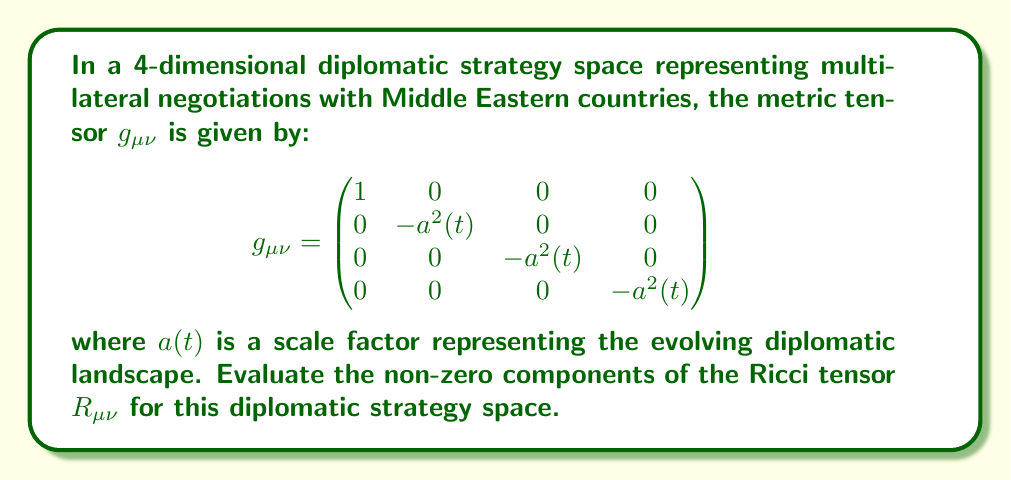What is the answer to this math problem? To evaluate the Ricci tensor, we'll follow these steps:

1) First, we need to calculate the Christoffel symbols $\Gamma^\lambda_{\mu\nu}$ using the metric tensor:

   $$\Gamma^\lambda_{\mu\nu} = \frac{1}{2}g^{\lambda\sigma}(\partial_\mu g_{\nu\sigma} + \partial_\nu g_{\mu\sigma} - \partial_\sigma g_{\mu\nu})$$

2) The non-zero Christoffel symbols are:
   
   $$\Gamma^0_{ii} = a\dot{a}, \quad \Gamma^i_{0i} = \Gamma^i_{i0} = \frac{\dot{a}}{a}$$
   
   where $i = 1, 2, 3$ and $\dot{a} = \frac{da}{dt}$

3) Next, we use the Christoffel symbols to calculate the Ricci tensor:

   $$R_{\mu\nu} = \partial_\lambda \Gamma^\lambda_{\mu\nu} - \partial_\nu \Gamma^\lambda_{\mu\lambda} + \Gamma^\lambda_{\lambda\sigma}\Gamma^\sigma_{\mu\nu} - \Gamma^\lambda_{\nu\sigma}\Gamma^\sigma_{\mu\lambda}$$

4) Calculating the non-zero components:

   For $R_{00}$:
   $$R_{00} = \partial_i \Gamma^i_{00} + \Gamma^i_{i\lambda}\Gamma^\lambda_{00} - \Gamma^i_{0\lambda}\Gamma^\lambda_{0i} = 3\frac{\ddot{a}}{a}$$

   For $R_{ii}$ (no sum on $i$):
   $$R_{ii} = \partial_0 \Gamma^0_{ii} + \partial_j \Gamma^j_{ii} - \Gamma^0_{i\lambda}\Gamma^\lambda_{0i} - \Gamma^j_{i\lambda}\Gamma^\lambda_{ij} = a\ddot{a} + 2\dot{a}^2$$

5) The non-zero components of the Ricci tensor are:

   $$R_{00} = 3\frac{\ddot{a}}{a}$$
   $$R_{11} = R_{22} = R_{33} = a\ddot{a} + 2\dot{a}^2$$

These components represent the curvature of the diplomatic strategy space, reflecting how diplomatic relations evolve over time in multi-lateral negotiations.
Answer: $R_{00} = 3\frac{\ddot{a}}{a}$, $R_{11} = R_{22} = R_{33} = a\ddot{a} + 2\dot{a}^2$ 